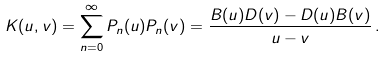<formula> <loc_0><loc_0><loc_500><loc_500>K ( u , v ) = \sum _ { n = 0 } ^ { \infty } P _ { n } ( u ) P _ { n } ( v ) = \frac { B ( u ) D ( v ) - D ( u ) B ( v ) } { u - v } \, .</formula> 